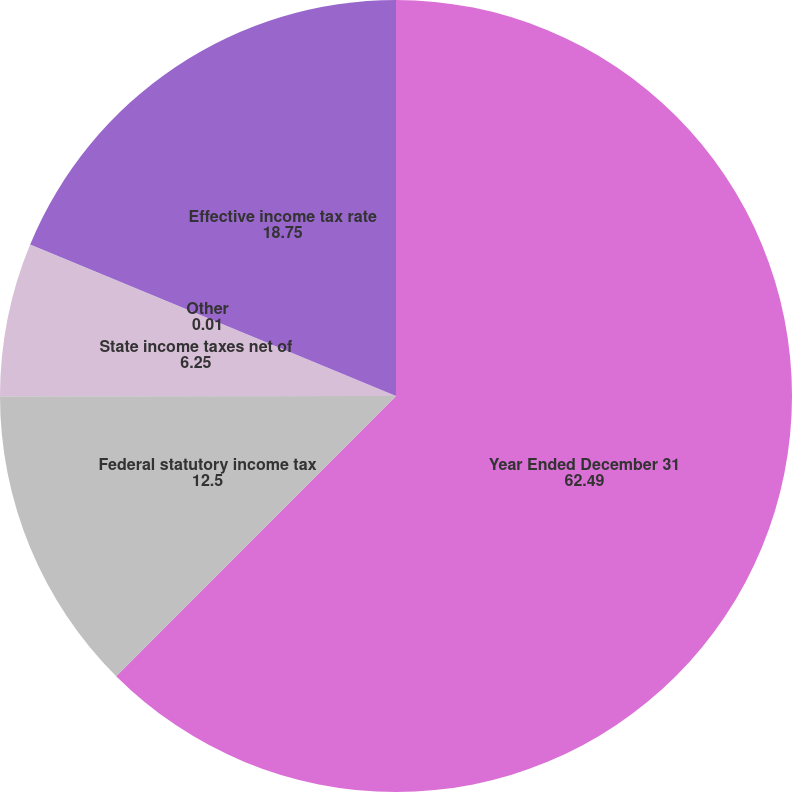<chart> <loc_0><loc_0><loc_500><loc_500><pie_chart><fcel>Year Ended December 31<fcel>Federal statutory income tax<fcel>State income taxes net of<fcel>Other<fcel>Effective income tax rate<nl><fcel>62.49%<fcel>12.5%<fcel>6.25%<fcel>0.01%<fcel>18.75%<nl></chart> 